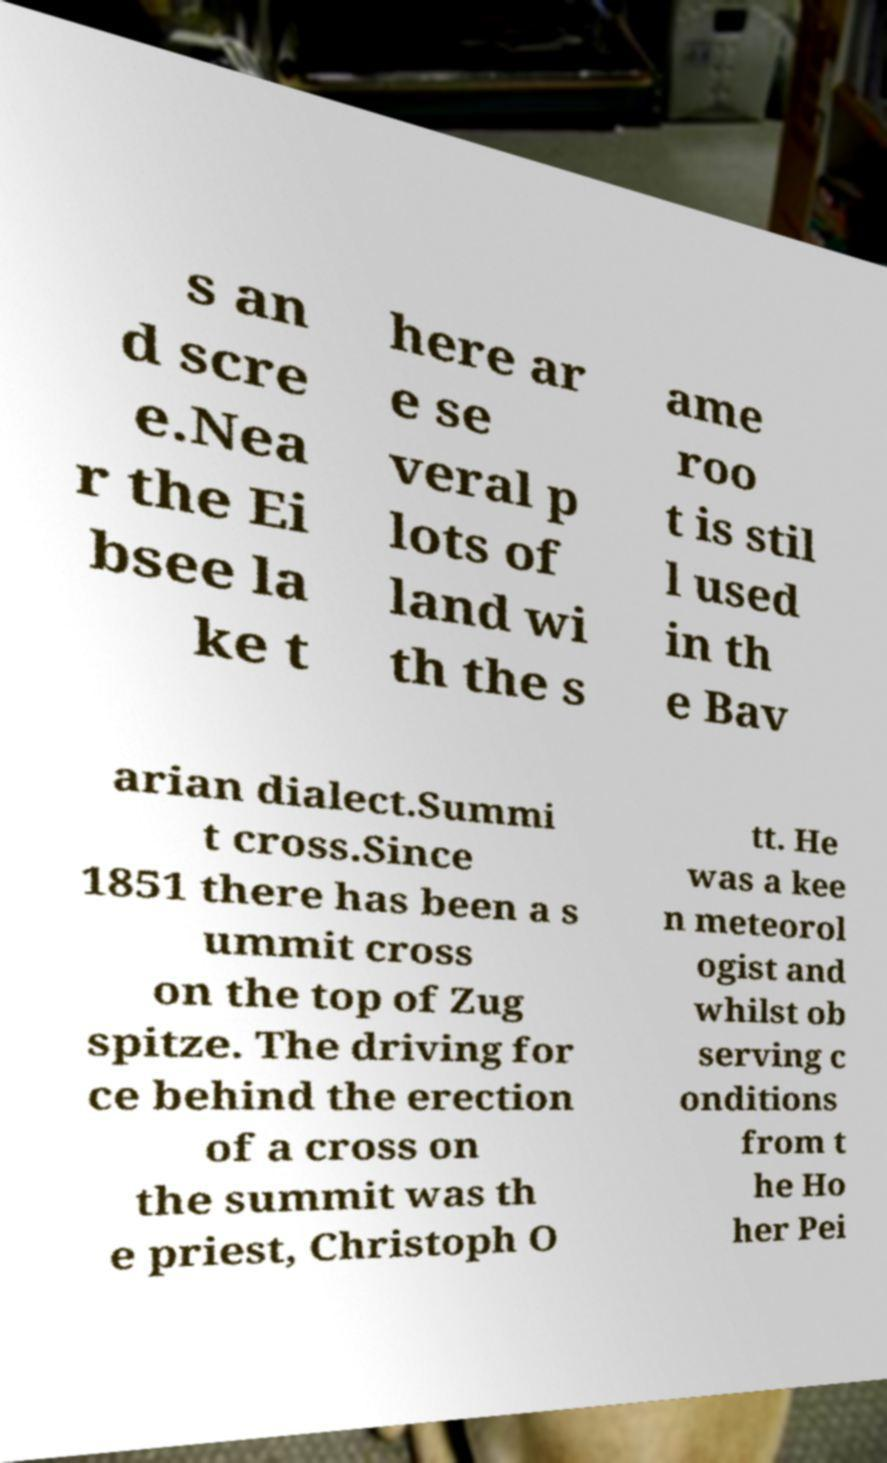Please identify and transcribe the text found in this image. s an d scre e.Nea r the Ei bsee la ke t here ar e se veral p lots of land wi th the s ame roo t is stil l used in th e Bav arian dialect.Summi t cross.Since 1851 there has been a s ummit cross on the top of Zug spitze. The driving for ce behind the erection of a cross on the summit was th e priest, Christoph O tt. He was a kee n meteorol ogist and whilst ob serving c onditions from t he Ho her Pei 